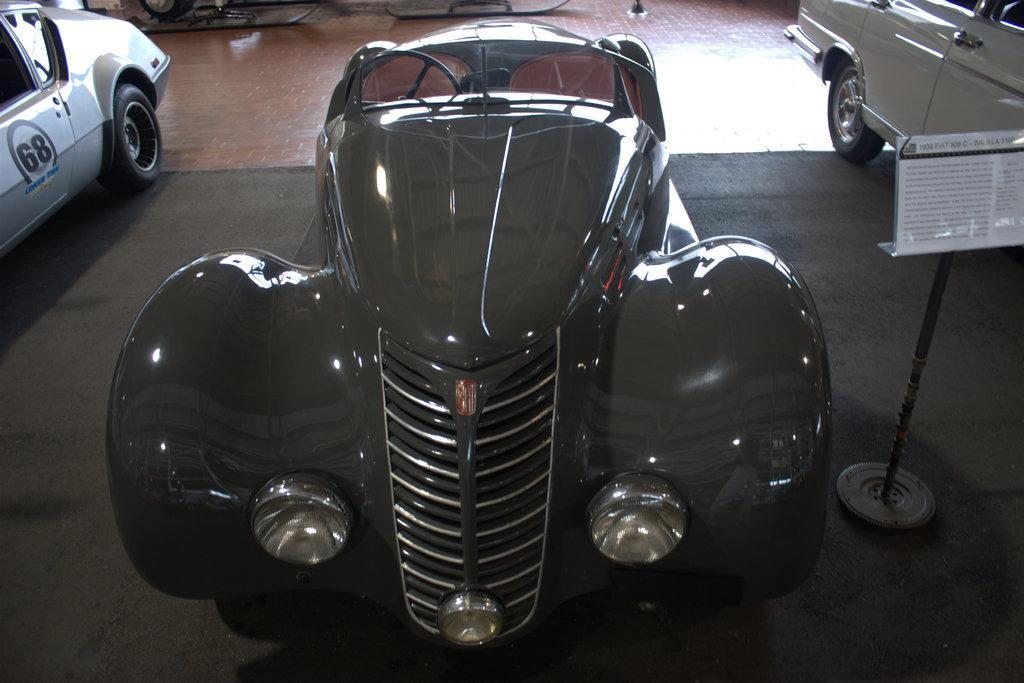How would you summarize this image in a sentence or two? In this image we can see some vehicles are on the floor. 